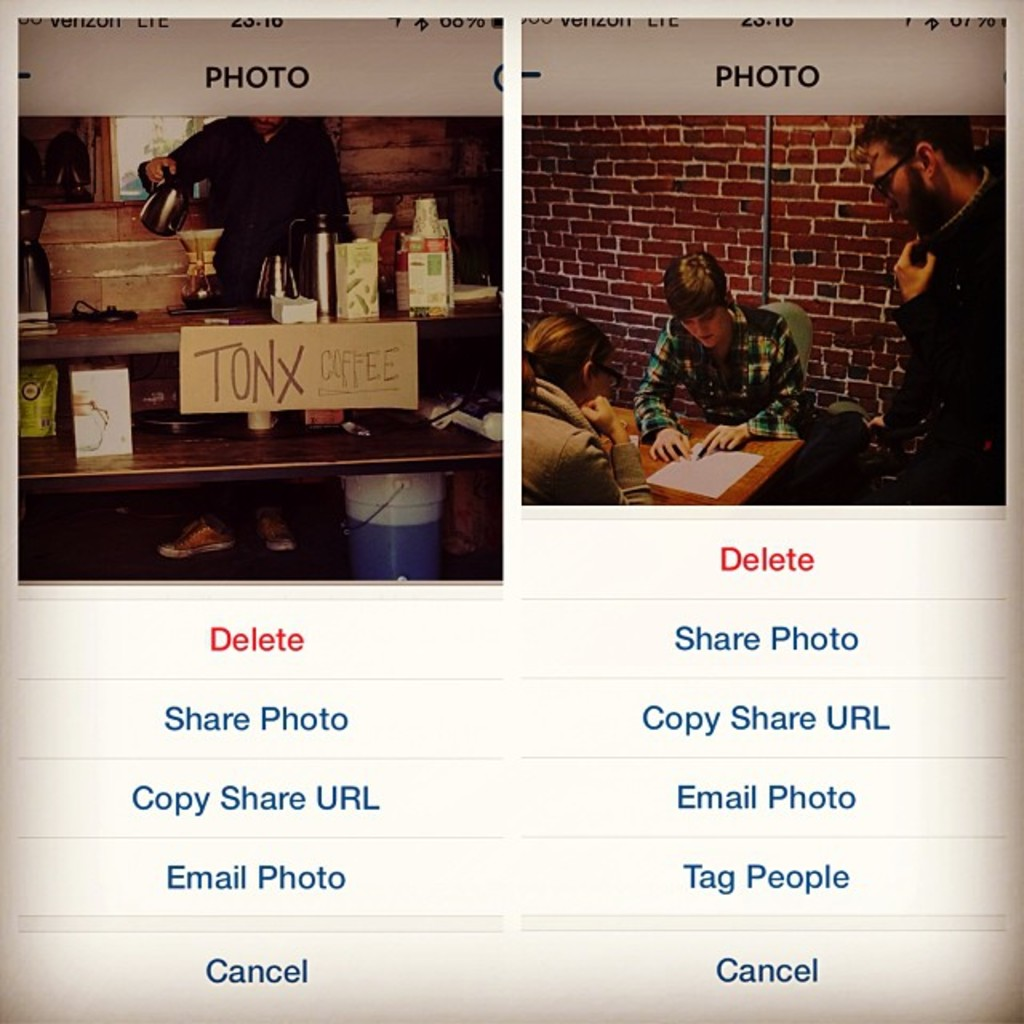What do the options below the images indicate about the user's interaction with these photos? The menu options such as 'Delete', 'Share Photo', 'Copy Share URL', 'Email Photo', and 'Tag People' indicate the user has various actions at their disposal to manage these pictures. These include sharing them with others via different channels, managing privacy by deleting or tagging people, and the ability to directly email the photos, likely reflecting typical use of a social media or photo-sharing platform. 